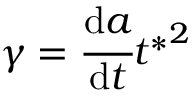Convert formula to latex. <formula><loc_0><loc_0><loc_500><loc_500>\gamma = \cfrac { d a } { d t } { t ^ { * } } ^ { 2 }</formula> 